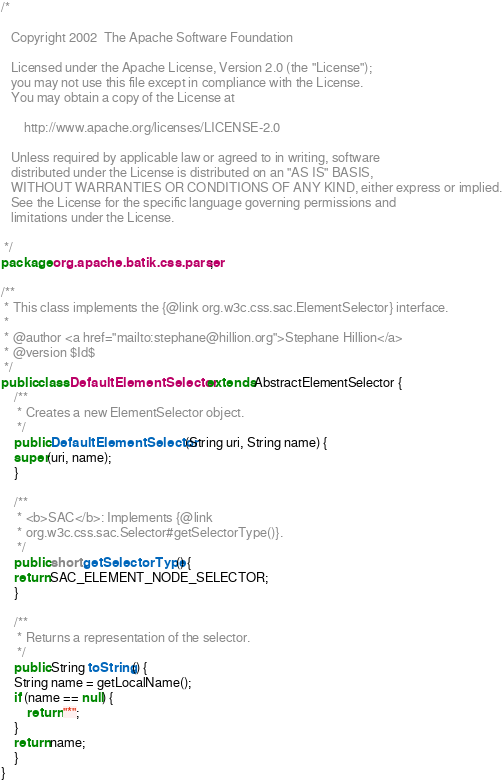Convert code to text. <code><loc_0><loc_0><loc_500><loc_500><_Java_>/*

   Copyright 2002  The Apache Software Foundation 

   Licensed under the Apache License, Version 2.0 (the "License");
   you may not use this file except in compliance with the License.
   You may obtain a copy of the License at

       http://www.apache.org/licenses/LICENSE-2.0

   Unless required by applicable law or agreed to in writing, software
   distributed under the License is distributed on an "AS IS" BASIS,
   WITHOUT WARRANTIES OR CONDITIONS OF ANY KIND, either express or implied.
   See the License for the specific language governing permissions and
   limitations under the License.

 */
package org.apache.batik.css.parser;

/**
 * This class implements the {@link org.w3c.css.sac.ElementSelector} interface.
 *
 * @author <a href="mailto:stephane@hillion.org">Stephane Hillion</a>
 * @version $Id$
 */
public class DefaultElementSelector extends AbstractElementSelector {
    /**
     * Creates a new ElementSelector object.
     */
    public DefaultElementSelector(String uri, String name) {
	super(uri, name);
    }

    /**
     * <b>SAC</b>: Implements {@link
     * org.w3c.css.sac.Selector#getSelectorType()}.
     */
    public short getSelectorType() {
	return SAC_ELEMENT_NODE_SELECTOR;
    }

    /**
     * Returns a representation of the selector.
     */
    public String toString() {
	String name = getLocalName();
	if (name == null) {
	    return "*";
	}
	return name;
    }
}
</code> 